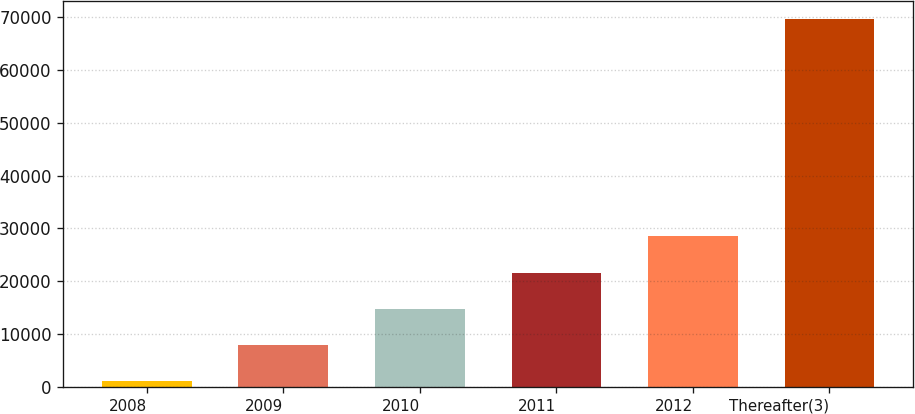Convert chart to OTSL. <chart><loc_0><loc_0><loc_500><loc_500><bar_chart><fcel>2008<fcel>2009<fcel>2010<fcel>2011<fcel>2012<fcel>Thereafter(3)<nl><fcel>1076<fcel>7929.7<fcel>14783.4<fcel>21637.1<fcel>28490.8<fcel>69613<nl></chart> 